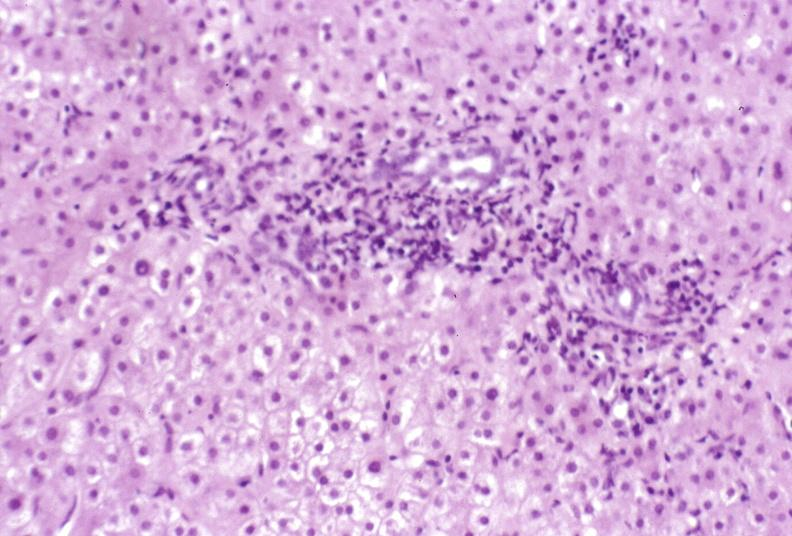what is present?
Answer the question using a single word or phrase. Hepatobiliary 